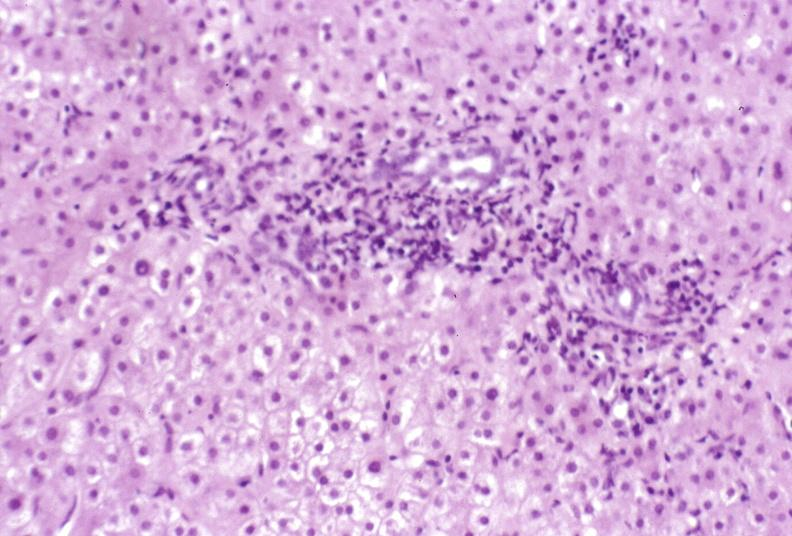what is present?
Answer the question using a single word or phrase. Hepatobiliary 